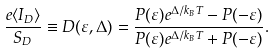Convert formula to latex. <formula><loc_0><loc_0><loc_500><loc_500>\frac { e \langle I _ { D } \rangle } { S _ { D } } \equiv D ( \varepsilon , \Delta ) = \frac { P ( \varepsilon ) e ^ { \Delta / k _ { B } T } - P ( - \varepsilon ) } { P ( \varepsilon ) e ^ { \Delta / k _ { B } T } + P ( - \varepsilon ) } .</formula> 